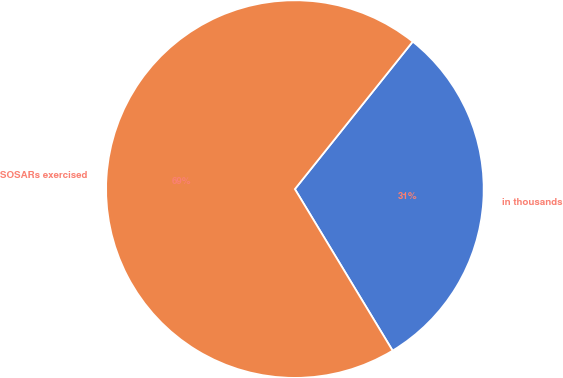Convert chart to OTSL. <chart><loc_0><loc_0><loc_500><loc_500><pie_chart><fcel>in thousands<fcel>SOSARs exercised<nl><fcel>30.61%<fcel>69.39%<nl></chart> 